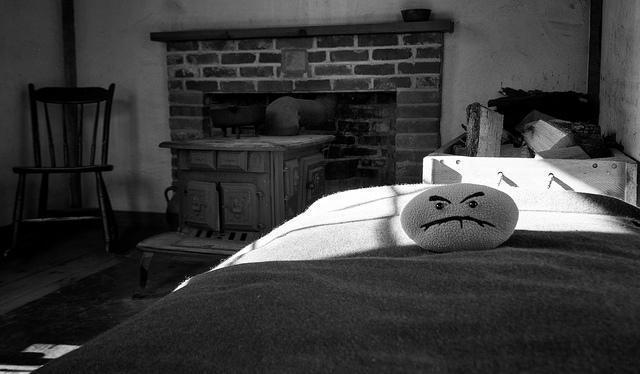How many chairs are there?
Give a very brief answer. 1. How many boats have red painted on them?
Give a very brief answer. 0. 